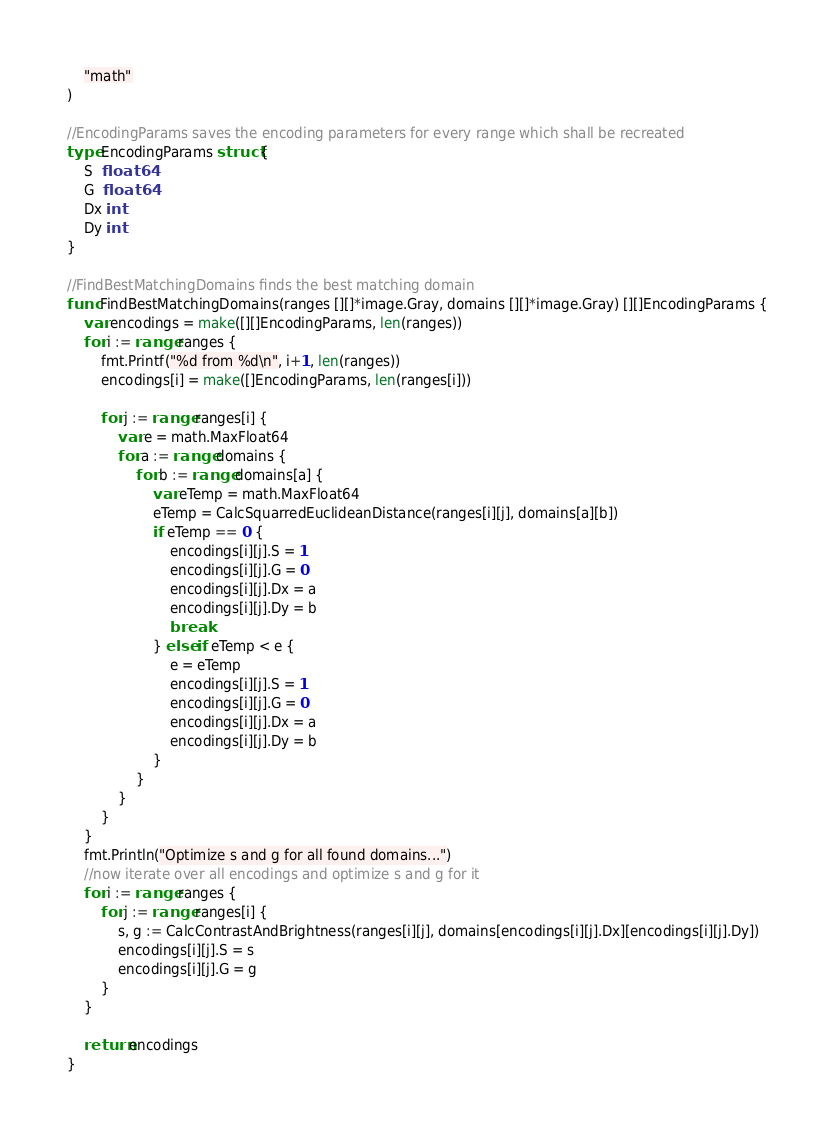<code> <loc_0><loc_0><loc_500><loc_500><_Go_>	"math"
)

//EncodingParams saves the encoding parameters for every range which shall be recreated
type EncodingParams struct {
	S  float64
	G  float64
	Dx int
	Dy int
}

//FindBestMatchingDomains finds the best matching domain
func FindBestMatchingDomains(ranges [][]*image.Gray, domains [][]*image.Gray) [][]EncodingParams {
	var encodings = make([][]EncodingParams, len(ranges))
	for i := range ranges {
		fmt.Printf("%d from %d\n", i+1, len(ranges))
		encodings[i] = make([]EncodingParams, len(ranges[i]))

		for j := range ranges[i] {
			var e = math.MaxFloat64
			for a := range domains {
				for b := range domains[a] {
					var eTemp = math.MaxFloat64
					eTemp = CalcSquarredEuclideanDistance(ranges[i][j], domains[a][b])
					if eTemp == 0 {
						encodings[i][j].S = 1
						encodings[i][j].G = 0
						encodings[i][j].Dx = a
						encodings[i][j].Dy = b
						break
					} else if eTemp < e {
						e = eTemp
						encodings[i][j].S = 1
						encodings[i][j].G = 0
						encodings[i][j].Dx = a
						encodings[i][j].Dy = b
					}
				}
			}
		}
	}
	fmt.Println("Optimize s and g for all found domains...")
	//now iterate over all encodings and optimize s and g for it
	for i := range ranges {
		for j := range ranges[i] {
			s, g := CalcContrastAndBrightness(ranges[i][j], domains[encodings[i][j].Dx][encodings[i][j].Dy])
			encodings[i][j].S = s
			encodings[i][j].G = g
		}
	}

	return encodings
}
</code> 